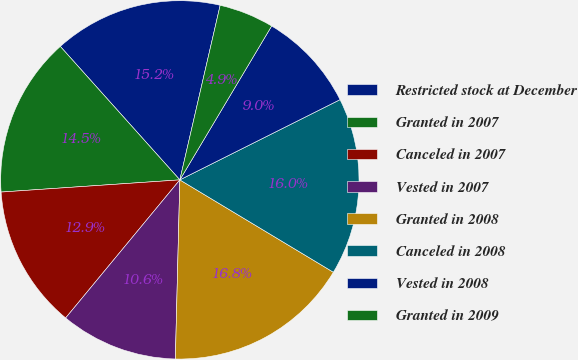Convert chart. <chart><loc_0><loc_0><loc_500><loc_500><pie_chart><fcel>Restricted stock at December<fcel>Granted in 2007<fcel>Canceled in 2007<fcel>Vested in 2007<fcel>Granted in 2008<fcel>Canceled in 2008<fcel>Vested in 2008<fcel>Granted in 2009<nl><fcel>15.24%<fcel>14.46%<fcel>12.92%<fcel>10.6%<fcel>16.78%<fcel>16.01%<fcel>9.05%<fcel>4.95%<nl></chart> 